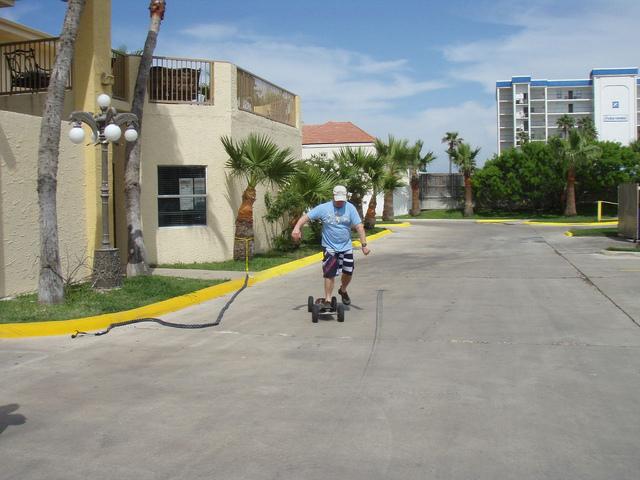Are the curbs painted yellow?
Be succinct. Yes. Could cars traveling the opposite direction as the skateboarder legally cross the street?
Keep it brief. Yes. How many lights are on the streetlight?
Quick response, please. 4. Is this man fat?
Quick response, please. Yes. 